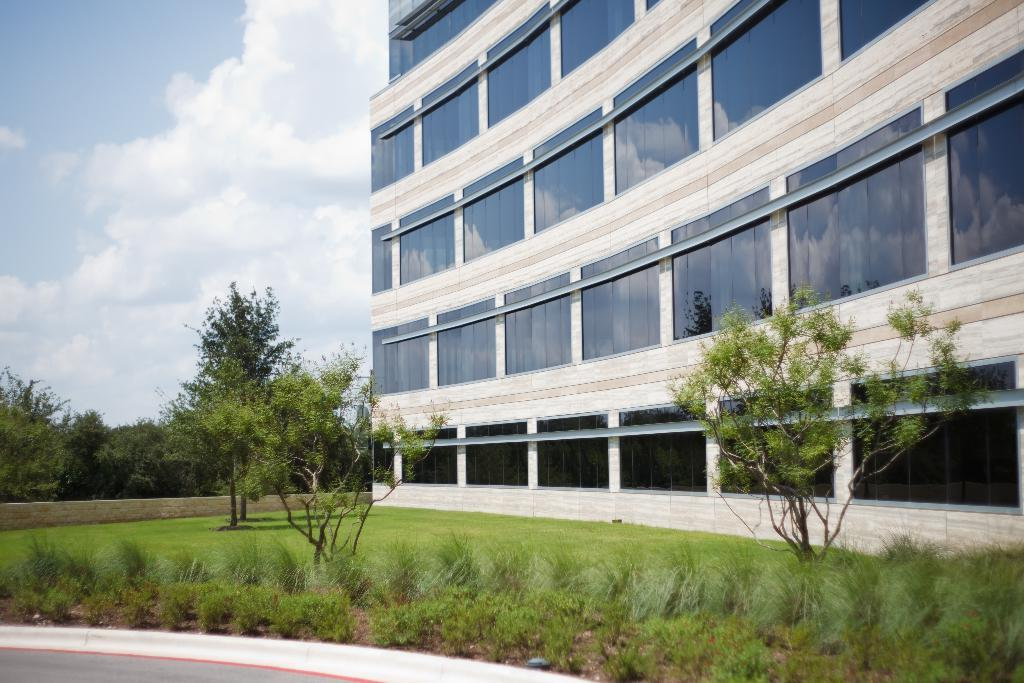What type of structure is present in the image? There is a building in the image. What natural elements can be seen in the image? There are trees, plants, and grass visible in the image. What is visible in the sky in the image? There are clouds in the sky. What can be seen in the windows of the building? The reflections of trees and clouds are visible in the windows of the building. What type of juice is being served in the image? There is no juice present in the image. What record is being played in the image? There is no record or music player present in the image. 